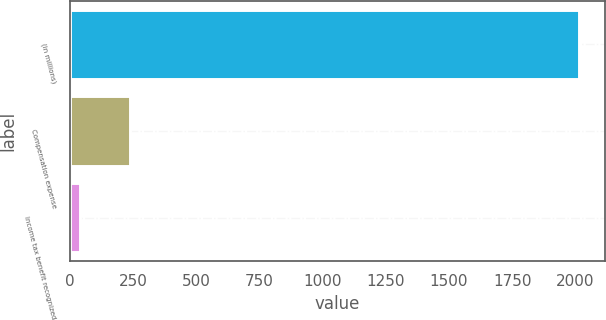Convert chart. <chart><loc_0><loc_0><loc_500><loc_500><bar_chart><fcel>(in millions)<fcel>Compensation expense<fcel>Income tax benefit recognized<nl><fcel>2016<fcel>236.34<fcel>38.6<nl></chart> 